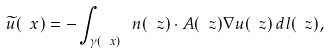Convert formula to latex. <formula><loc_0><loc_0><loc_500><loc_500>\widetilde { u } ( \ x ) = - \int _ { \gamma ( \ x ) } \ n ( \ z ) \cdot A ( \ z ) \nabla u ( \ z ) \, d l ( \ z ) ,</formula> 